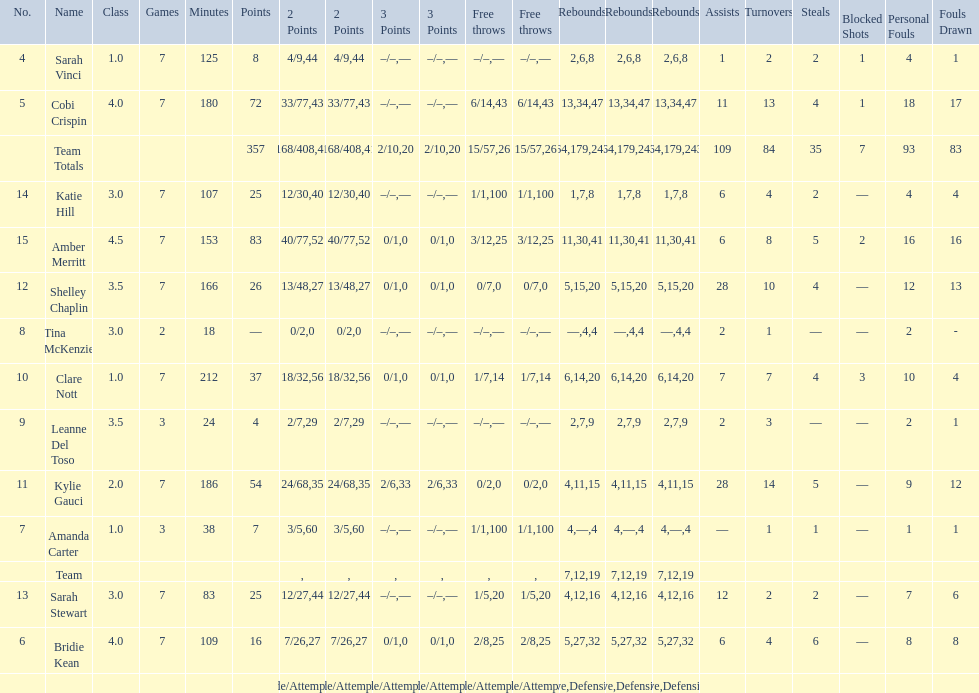Give me the full table as a dictionary. {'header': ['No.', 'Name', 'Class', 'Games', 'Minutes', 'Points', '2 Points', '2 Points', '3 Points', '3 Points', 'Free throws', 'Free throws', 'Rebounds', 'Rebounds', 'Rebounds', 'Assists', 'Turnovers', 'Steals', 'Blocked Shots', 'Personal Fouls', 'Fouls Drawn'], 'rows': [['4', 'Sarah Vinci', '1.0', '7', '125', '8', '4/9', '44', '–/–', '—', '–/–', '—', '2', '6', '8', '1', '2', '2', '1', '4', '1'], ['5', 'Cobi Crispin', '4.0', '7', '180', '72', '33/77', '43', '–/–', '—', '6/14', '43', '13', '34', '47', '11', '13', '4', '1', '18', '17'], ['', 'Team Totals', '', '', '', '357', '168/408', '41', '2/10', '20', '15/57', '26', '64', '179', '243', '109', '84', '35', '7', '93', '83'], ['14', 'Katie Hill', '3.0', '7', '107', '25', '12/30', '40', '–/–', '—', '1/1', '100', '1', '7', '8', '6', '4', '2', '—', '4', '4'], ['15', 'Amber Merritt', '4.5', '7', '153', '83', '40/77', '52', '0/1', '0', '3/12', '25', '11', '30', '41', '6', '8', '5', '2', '16', '16'], ['12', 'Shelley Chaplin', '3.5', '7', '166', '26', '13/48', '27', '0/1', '0', '0/7', '0', '5', '15', '20', '28', '10', '4', '—', '12', '13'], ['8', 'Tina McKenzie', '3.0', '2', '18', '—', '0/2', '0', '–/–', '—', '–/–', '—', '—', '4', '4', '2', '1', '—', '—', '2', '-'], ['10', 'Clare Nott', '1.0', '7', '212', '37', '18/32', '56', '0/1', '0', '1/7', '14', '6', '14', '20', '7', '7', '4', '3', '10', '4'], ['9', 'Leanne Del Toso', '3.5', '3', '24', '4', '2/7', '29', '–/–', '—', '–/–', '—', '2', '7', '9', '2', '3', '—', '—', '2', '1'], ['11', 'Kylie Gauci', '2.0', '7', '186', '54', '24/68', '35', '2/6', '33', '0/2', '0', '4', '11', '15', '28', '14', '5', '—', '9', '12'], ['7', 'Amanda Carter', '1.0', '3', '38', '7', '3/5', '60', '–/–', '—', '1/1', '100', '4', '—', '4', '—', '1', '1', '—', '1', '1'], ['', 'Team', '', '', '', '', '', '', '', '', '', '', '7', '12', '19', '', '', '', '', '', ''], ['13', 'Sarah Stewart', '3.0', '7', '83', '25', '12/27', '44', '–/–', '—', '1/5', '20', '4', '12', '16', '12', '2', '2', '—', '7', '6'], ['6', 'Bridie Kean', '4.0', '7', '109', '16', '7/26', '27', '0/1', '0', '2/8', '25', '5', '27', '32', '6', '4', '6', '—', '8', '8'], ['', '', '', '', '', '', 'Made/Attempts', '%', 'Made/Attempts', '%', 'Made/Attempts', '%', 'Offensive', 'Defensive', 'Total', '', '', '', '', '', '']]} Who is the first person on the list to play less than 20 minutes? Tina McKenzie. 